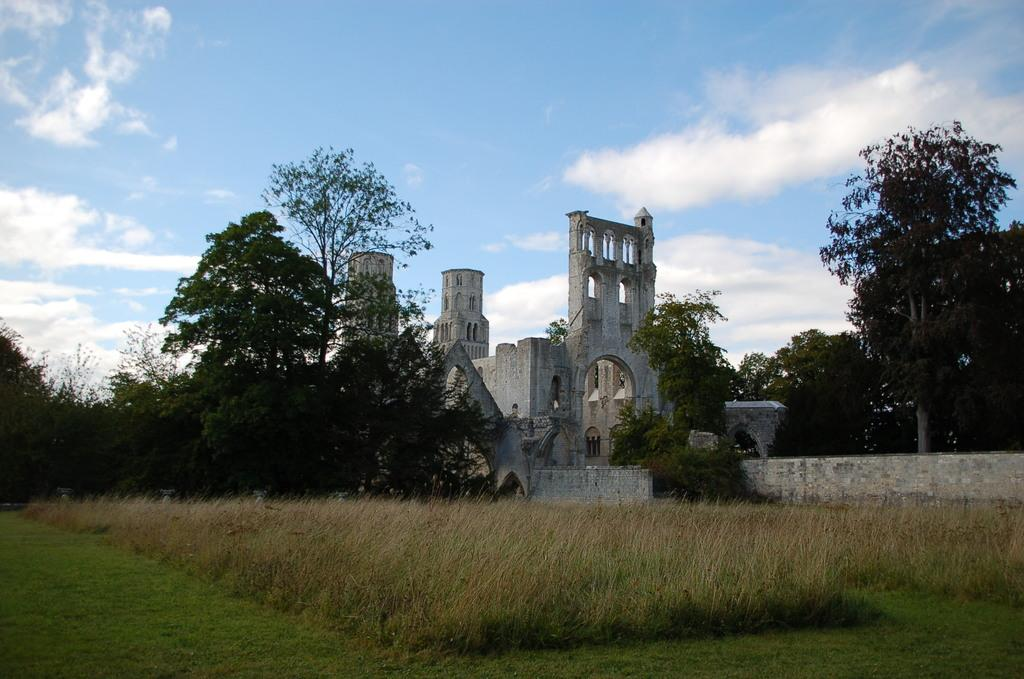What type of structure is present in the image? There is a building in the image. What else can be seen in the image besides the building? There is a wall, a group of trees, plants, and grass in the image. How would you describe the sky in the image? The sky is visible in the image, and it looks cloudy. What type of silver object is being discussed by the ducks in the image? There are no ducks present in the image, and therefore no discussion or silver object can be observed. 